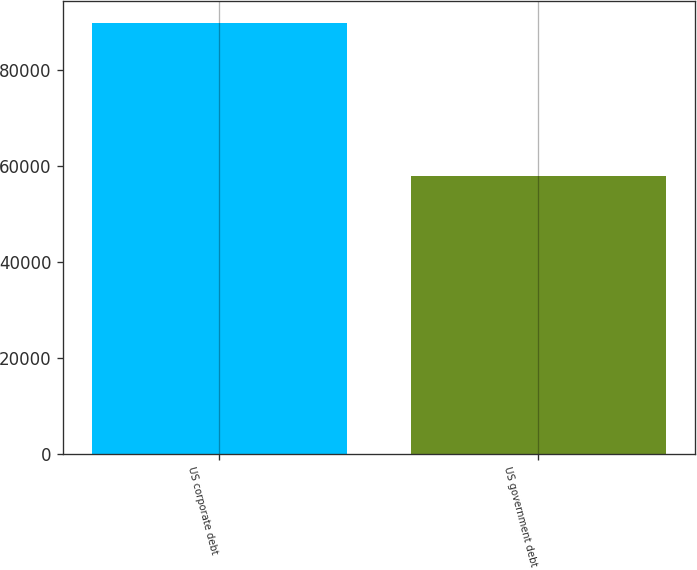<chart> <loc_0><loc_0><loc_500><loc_500><bar_chart><fcel>US corporate debt<fcel>US government debt<nl><fcel>89956<fcel>57936<nl></chart> 